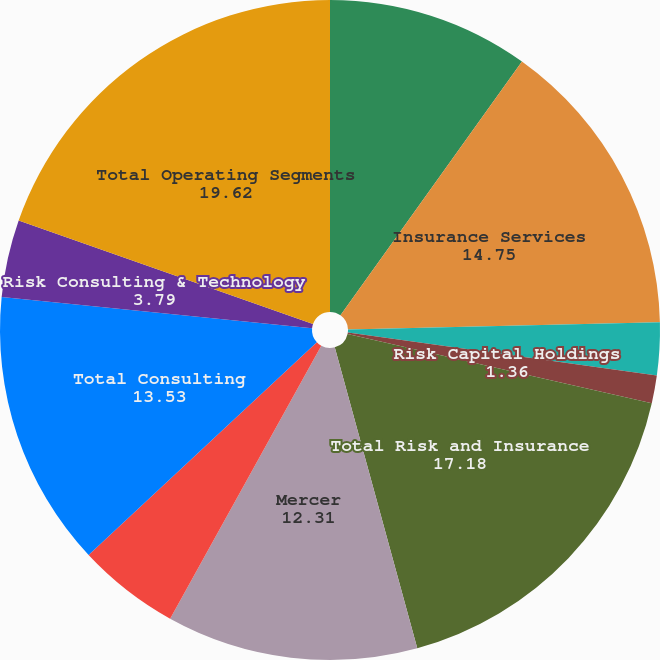Convert chart to OTSL. <chart><loc_0><loc_0><loc_500><loc_500><pie_chart><fcel>For the Years Ended December<fcel>Insurance Services<fcel>Reinsurance Services<fcel>Risk Capital Holdings<fcel>Total Risk and Insurance<fcel>Mercer<fcel>Oliver Wyman Group<fcel>Total Consulting<fcel>Risk Consulting & Technology<fcel>Total Operating Segments<nl><fcel>9.88%<fcel>14.75%<fcel>2.57%<fcel>1.36%<fcel>17.18%<fcel>12.31%<fcel>5.01%<fcel>13.53%<fcel>3.79%<fcel>19.62%<nl></chart> 